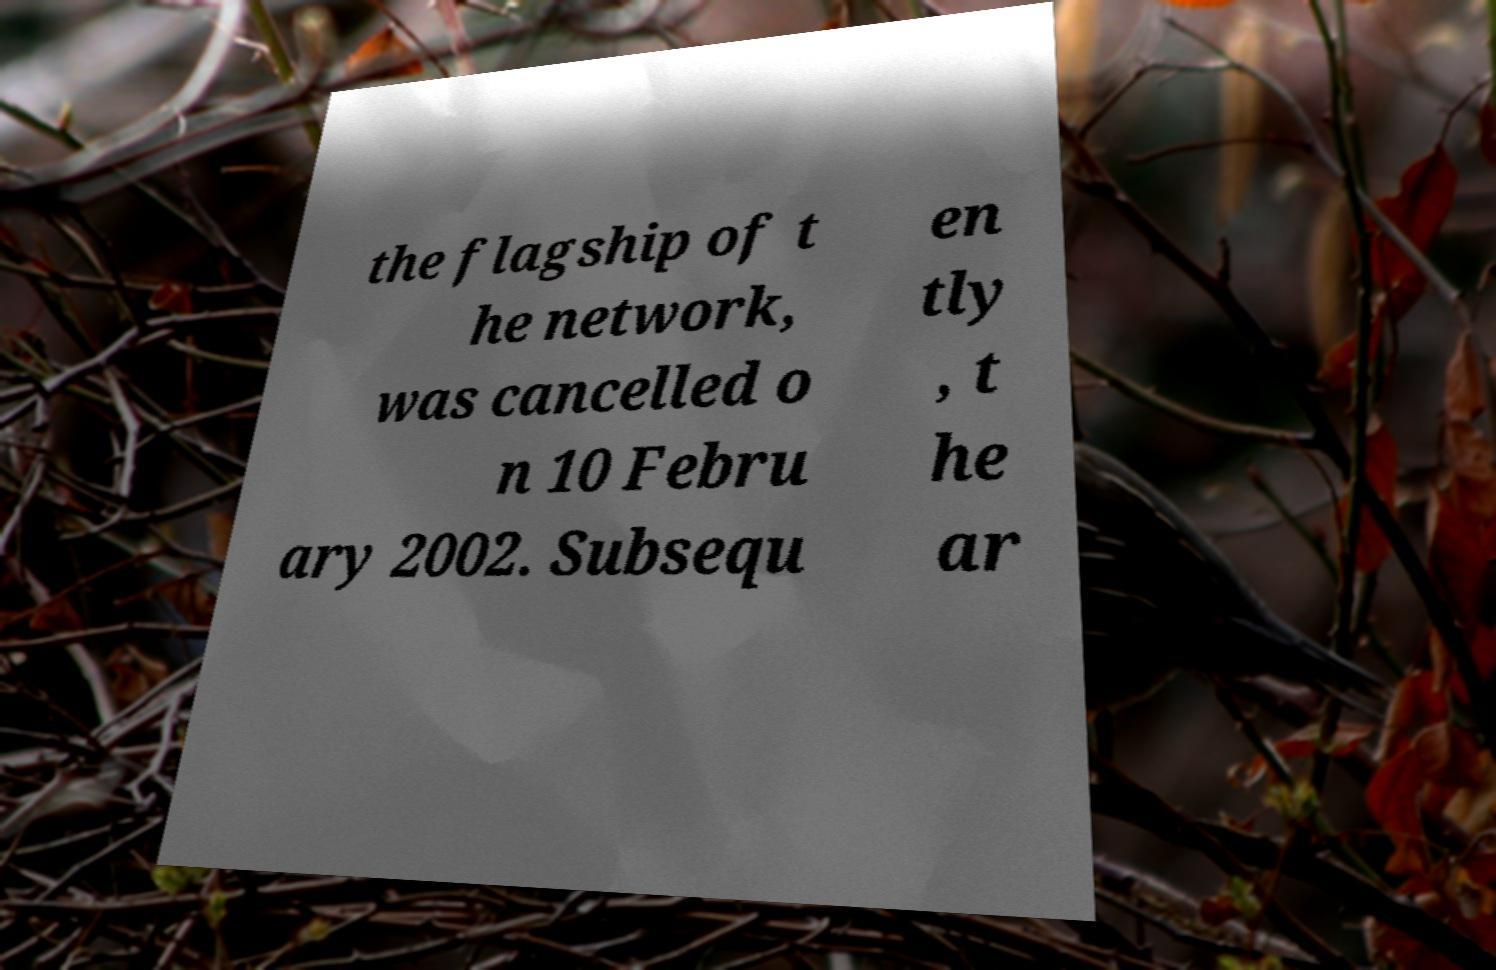For documentation purposes, I need the text within this image transcribed. Could you provide that? the flagship of t he network, was cancelled o n 10 Febru ary 2002. Subsequ en tly , t he ar 